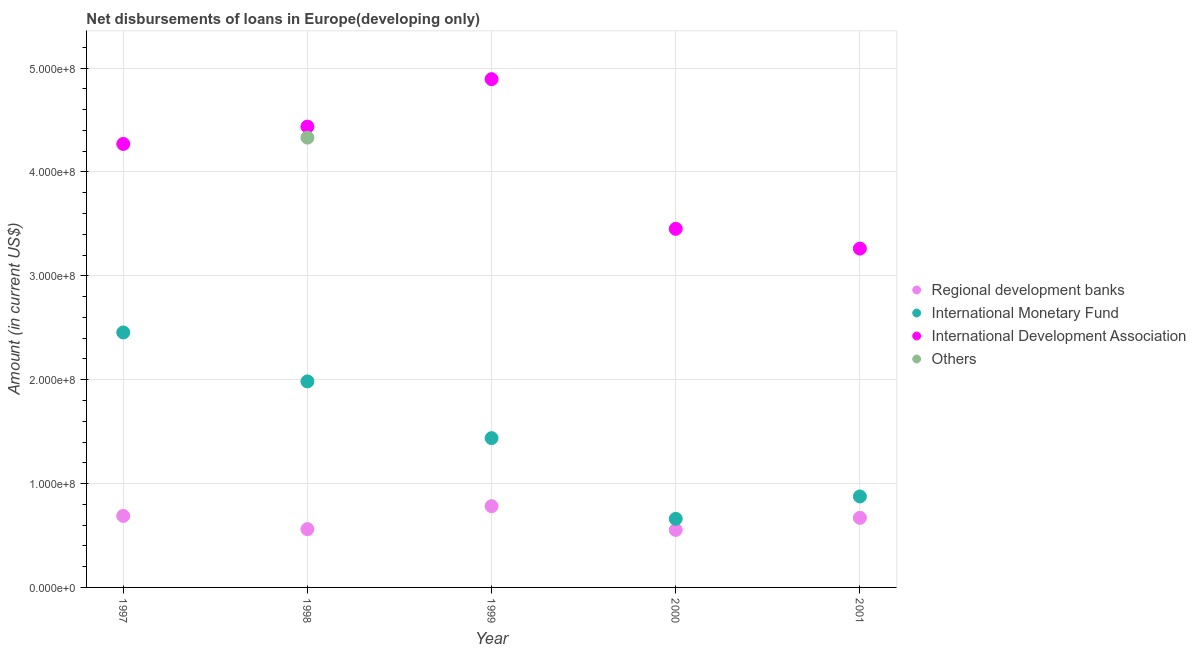How many different coloured dotlines are there?
Provide a short and direct response. 4. What is the amount of loan disimbursed by regional development banks in 1997?
Keep it short and to the point. 6.89e+07. Across all years, what is the maximum amount of loan disimbursed by other organisations?
Offer a terse response. 4.33e+08. Across all years, what is the minimum amount of loan disimbursed by international monetary fund?
Your answer should be very brief. 6.60e+07. In which year was the amount of loan disimbursed by international development association maximum?
Your answer should be compact. 1999. What is the total amount of loan disimbursed by other organisations in the graph?
Provide a short and direct response. 4.33e+08. What is the difference between the amount of loan disimbursed by regional development banks in 1997 and that in 1998?
Provide a short and direct response. 1.27e+07. What is the difference between the amount of loan disimbursed by international development association in 1997 and the amount of loan disimbursed by regional development banks in 2001?
Your answer should be very brief. 3.60e+08. What is the average amount of loan disimbursed by regional development banks per year?
Ensure brevity in your answer.  6.51e+07. In the year 1999, what is the difference between the amount of loan disimbursed by international monetary fund and amount of loan disimbursed by international development association?
Make the answer very short. -3.46e+08. In how many years, is the amount of loan disimbursed by international monetary fund greater than 20000000 US$?
Offer a very short reply. 5. What is the ratio of the amount of loan disimbursed by international development association in 1998 to that in 2001?
Your answer should be compact. 1.36. Is the amount of loan disimbursed by international monetary fund in 1997 less than that in 2001?
Your answer should be very brief. No. Is the difference between the amount of loan disimbursed by international development association in 1997 and 2001 greater than the difference between the amount of loan disimbursed by international monetary fund in 1997 and 2001?
Your response must be concise. No. What is the difference between the highest and the second highest amount of loan disimbursed by regional development banks?
Provide a short and direct response. 9.38e+06. What is the difference between the highest and the lowest amount of loan disimbursed by regional development banks?
Provide a succinct answer. 2.29e+07. In how many years, is the amount of loan disimbursed by international development association greater than the average amount of loan disimbursed by international development association taken over all years?
Provide a short and direct response. 3. Is it the case that in every year, the sum of the amount of loan disimbursed by regional development banks and amount of loan disimbursed by international monetary fund is greater than the amount of loan disimbursed by international development association?
Provide a succinct answer. No. Is the amount of loan disimbursed by international development association strictly less than the amount of loan disimbursed by international monetary fund over the years?
Your response must be concise. No. How many years are there in the graph?
Your answer should be very brief. 5. What is the difference between two consecutive major ticks on the Y-axis?
Provide a succinct answer. 1.00e+08. Are the values on the major ticks of Y-axis written in scientific E-notation?
Your answer should be compact. Yes. Does the graph contain any zero values?
Keep it short and to the point. Yes. Does the graph contain grids?
Your response must be concise. Yes. Where does the legend appear in the graph?
Give a very brief answer. Center right. How many legend labels are there?
Provide a short and direct response. 4. How are the legend labels stacked?
Your answer should be very brief. Vertical. What is the title of the graph?
Make the answer very short. Net disbursements of loans in Europe(developing only). What is the label or title of the Y-axis?
Give a very brief answer. Amount (in current US$). What is the Amount (in current US$) in Regional development banks in 1997?
Offer a very short reply. 6.89e+07. What is the Amount (in current US$) in International Monetary Fund in 1997?
Provide a succinct answer. 2.45e+08. What is the Amount (in current US$) in International Development Association in 1997?
Offer a terse response. 4.27e+08. What is the Amount (in current US$) of Others in 1997?
Provide a succinct answer. 0. What is the Amount (in current US$) in Regional development banks in 1998?
Offer a very short reply. 5.61e+07. What is the Amount (in current US$) in International Monetary Fund in 1998?
Give a very brief answer. 1.98e+08. What is the Amount (in current US$) of International Development Association in 1998?
Offer a very short reply. 4.44e+08. What is the Amount (in current US$) in Others in 1998?
Your answer should be very brief. 4.33e+08. What is the Amount (in current US$) in Regional development banks in 1999?
Make the answer very short. 7.82e+07. What is the Amount (in current US$) in International Monetary Fund in 1999?
Provide a succinct answer. 1.44e+08. What is the Amount (in current US$) of International Development Association in 1999?
Your answer should be very brief. 4.89e+08. What is the Amount (in current US$) in Others in 1999?
Ensure brevity in your answer.  0. What is the Amount (in current US$) of Regional development banks in 2000?
Ensure brevity in your answer.  5.54e+07. What is the Amount (in current US$) of International Monetary Fund in 2000?
Your answer should be compact. 6.60e+07. What is the Amount (in current US$) in International Development Association in 2000?
Offer a terse response. 3.45e+08. What is the Amount (in current US$) of Regional development banks in 2001?
Your answer should be compact. 6.70e+07. What is the Amount (in current US$) in International Monetary Fund in 2001?
Provide a succinct answer. 8.76e+07. What is the Amount (in current US$) of International Development Association in 2001?
Your response must be concise. 3.26e+08. What is the Amount (in current US$) in Others in 2001?
Ensure brevity in your answer.  0. Across all years, what is the maximum Amount (in current US$) of Regional development banks?
Provide a short and direct response. 7.82e+07. Across all years, what is the maximum Amount (in current US$) in International Monetary Fund?
Offer a very short reply. 2.45e+08. Across all years, what is the maximum Amount (in current US$) in International Development Association?
Ensure brevity in your answer.  4.89e+08. Across all years, what is the maximum Amount (in current US$) of Others?
Your response must be concise. 4.33e+08. Across all years, what is the minimum Amount (in current US$) in Regional development banks?
Offer a terse response. 5.54e+07. Across all years, what is the minimum Amount (in current US$) in International Monetary Fund?
Provide a short and direct response. 6.60e+07. Across all years, what is the minimum Amount (in current US$) of International Development Association?
Offer a terse response. 3.26e+08. Across all years, what is the minimum Amount (in current US$) in Others?
Your answer should be compact. 0. What is the total Amount (in current US$) of Regional development banks in the graph?
Make the answer very short. 3.26e+08. What is the total Amount (in current US$) of International Monetary Fund in the graph?
Give a very brief answer. 7.41e+08. What is the total Amount (in current US$) of International Development Association in the graph?
Provide a succinct answer. 2.03e+09. What is the total Amount (in current US$) in Others in the graph?
Provide a short and direct response. 4.33e+08. What is the difference between the Amount (in current US$) of Regional development banks in 1997 and that in 1998?
Your answer should be compact. 1.27e+07. What is the difference between the Amount (in current US$) in International Monetary Fund in 1997 and that in 1998?
Offer a very short reply. 4.71e+07. What is the difference between the Amount (in current US$) of International Development Association in 1997 and that in 1998?
Give a very brief answer. -1.67e+07. What is the difference between the Amount (in current US$) of Regional development banks in 1997 and that in 1999?
Offer a terse response. -9.38e+06. What is the difference between the Amount (in current US$) of International Monetary Fund in 1997 and that in 1999?
Offer a terse response. 1.02e+08. What is the difference between the Amount (in current US$) of International Development Association in 1997 and that in 1999?
Give a very brief answer. -6.24e+07. What is the difference between the Amount (in current US$) in Regional development banks in 1997 and that in 2000?
Your answer should be compact. 1.35e+07. What is the difference between the Amount (in current US$) in International Monetary Fund in 1997 and that in 2000?
Offer a terse response. 1.79e+08. What is the difference between the Amount (in current US$) of International Development Association in 1997 and that in 2000?
Give a very brief answer. 8.17e+07. What is the difference between the Amount (in current US$) in Regional development banks in 1997 and that in 2001?
Offer a very short reply. 1.84e+06. What is the difference between the Amount (in current US$) in International Monetary Fund in 1997 and that in 2001?
Keep it short and to the point. 1.58e+08. What is the difference between the Amount (in current US$) of International Development Association in 1997 and that in 2001?
Give a very brief answer. 1.01e+08. What is the difference between the Amount (in current US$) of Regional development banks in 1998 and that in 1999?
Your response must be concise. -2.21e+07. What is the difference between the Amount (in current US$) of International Monetary Fund in 1998 and that in 1999?
Provide a succinct answer. 5.46e+07. What is the difference between the Amount (in current US$) in International Development Association in 1998 and that in 1999?
Give a very brief answer. -4.57e+07. What is the difference between the Amount (in current US$) in Regional development banks in 1998 and that in 2000?
Provide a short and direct response. 7.39e+05. What is the difference between the Amount (in current US$) in International Monetary Fund in 1998 and that in 2000?
Ensure brevity in your answer.  1.32e+08. What is the difference between the Amount (in current US$) in International Development Association in 1998 and that in 2000?
Offer a terse response. 9.84e+07. What is the difference between the Amount (in current US$) in Regional development banks in 1998 and that in 2001?
Your answer should be compact. -1.09e+07. What is the difference between the Amount (in current US$) of International Monetary Fund in 1998 and that in 2001?
Make the answer very short. 1.11e+08. What is the difference between the Amount (in current US$) of International Development Association in 1998 and that in 2001?
Make the answer very short. 1.17e+08. What is the difference between the Amount (in current US$) in Regional development banks in 1999 and that in 2000?
Make the answer very short. 2.29e+07. What is the difference between the Amount (in current US$) in International Monetary Fund in 1999 and that in 2000?
Make the answer very short. 7.77e+07. What is the difference between the Amount (in current US$) of International Development Association in 1999 and that in 2000?
Provide a succinct answer. 1.44e+08. What is the difference between the Amount (in current US$) in Regional development banks in 1999 and that in 2001?
Offer a terse response. 1.12e+07. What is the difference between the Amount (in current US$) of International Monetary Fund in 1999 and that in 2001?
Offer a terse response. 5.62e+07. What is the difference between the Amount (in current US$) of International Development Association in 1999 and that in 2001?
Ensure brevity in your answer.  1.63e+08. What is the difference between the Amount (in current US$) in Regional development banks in 2000 and that in 2001?
Give a very brief answer. -1.16e+07. What is the difference between the Amount (in current US$) in International Monetary Fund in 2000 and that in 2001?
Offer a terse response. -2.15e+07. What is the difference between the Amount (in current US$) of International Development Association in 2000 and that in 2001?
Provide a succinct answer. 1.90e+07. What is the difference between the Amount (in current US$) of Regional development banks in 1997 and the Amount (in current US$) of International Monetary Fund in 1998?
Give a very brief answer. -1.30e+08. What is the difference between the Amount (in current US$) in Regional development banks in 1997 and the Amount (in current US$) in International Development Association in 1998?
Your answer should be compact. -3.75e+08. What is the difference between the Amount (in current US$) of Regional development banks in 1997 and the Amount (in current US$) of Others in 1998?
Offer a terse response. -3.64e+08. What is the difference between the Amount (in current US$) in International Monetary Fund in 1997 and the Amount (in current US$) in International Development Association in 1998?
Provide a short and direct response. -1.98e+08. What is the difference between the Amount (in current US$) of International Monetary Fund in 1997 and the Amount (in current US$) of Others in 1998?
Your answer should be compact. -1.88e+08. What is the difference between the Amount (in current US$) in International Development Association in 1997 and the Amount (in current US$) in Others in 1998?
Provide a short and direct response. -6.06e+06. What is the difference between the Amount (in current US$) in Regional development banks in 1997 and the Amount (in current US$) in International Monetary Fund in 1999?
Make the answer very short. -7.49e+07. What is the difference between the Amount (in current US$) of Regional development banks in 1997 and the Amount (in current US$) of International Development Association in 1999?
Give a very brief answer. -4.21e+08. What is the difference between the Amount (in current US$) in International Monetary Fund in 1997 and the Amount (in current US$) in International Development Association in 1999?
Your answer should be very brief. -2.44e+08. What is the difference between the Amount (in current US$) in Regional development banks in 1997 and the Amount (in current US$) in International Monetary Fund in 2000?
Provide a succinct answer. 2.83e+06. What is the difference between the Amount (in current US$) in Regional development banks in 1997 and the Amount (in current US$) in International Development Association in 2000?
Offer a very short reply. -2.76e+08. What is the difference between the Amount (in current US$) in International Monetary Fund in 1997 and the Amount (in current US$) in International Development Association in 2000?
Your response must be concise. -9.98e+07. What is the difference between the Amount (in current US$) of Regional development banks in 1997 and the Amount (in current US$) of International Monetary Fund in 2001?
Your response must be concise. -1.87e+07. What is the difference between the Amount (in current US$) in Regional development banks in 1997 and the Amount (in current US$) in International Development Association in 2001?
Your answer should be compact. -2.57e+08. What is the difference between the Amount (in current US$) of International Monetary Fund in 1997 and the Amount (in current US$) of International Development Association in 2001?
Your response must be concise. -8.08e+07. What is the difference between the Amount (in current US$) in Regional development banks in 1998 and the Amount (in current US$) in International Monetary Fund in 1999?
Provide a short and direct response. -8.76e+07. What is the difference between the Amount (in current US$) of Regional development banks in 1998 and the Amount (in current US$) of International Development Association in 1999?
Ensure brevity in your answer.  -4.33e+08. What is the difference between the Amount (in current US$) in International Monetary Fund in 1998 and the Amount (in current US$) in International Development Association in 1999?
Offer a terse response. -2.91e+08. What is the difference between the Amount (in current US$) in Regional development banks in 1998 and the Amount (in current US$) in International Monetary Fund in 2000?
Keep it short and to the point. -9.90e+06. What is the difference between the Amount (in current US$) in Regional development banks in 1998 and the Amount (in current US$) in International Development Association in 2000?
Offer a terse response. -2.89e+08. What is the difference between the Amount (in current US$) of International Monetary Fund in 1998 and the Amount (in current US$) of International Development Association in 2000?
Provide a short and direct response. -1.47e+08. What is the difference between the Amount (in current US$) of Regional development banks in 1998 and the Amount (in current US$) of International Monetary Fund in 2001?
Your answer should be compact. -3.15e+07. What is the difference between the Amount (in current US$) of Regional development banks in 1998 and the Amount (in current US$) of International Development Association in 2001?
Offer a very short reply. -2.70e+08. What is the difference between the Amount (in current US$) in International Monetary Fund in 1998 and the Amount (in current US$) in International Development Association in 2001?
Offer a terse response. -1.28e+08. What is the difference between the Amount (in current US$) in Regional development banks in 1999 and the Amount (in current US$) in International Monetary Fund in 2000?
Make the answer very short. 1.22e+07. What is the difference between the Amount (in current US$) of Regional development banks in 1999 and the Amount (in current US$) of International Development Association in 2000?
Your response must be concise. -2.67e+08. What is the difference between the Amount (in current US$) in International Monetary Fund in 1999 and the Amount (in current US$) in International Development Association in 2000?
Give a very brief answer. -2.01e+08. What is the difference between the Amount (in current US$) of Regional development banks in 1999 and the Amount (in current US$) of International Monetary Fund in 2001?
Your response must be concise. -9.34e+06. What is the difference between the Amount (in current US$) in Regional development banks in 1999 and the Amount (in current US$) in International Development Association in 2001?
Your response must be concise. -2.48e+08. What is the difference between the Amount (in current US$) in International Monetary Fund in 1999 and the Amount (in current US$) in International Development Association in 2001?
Your answer should be very brief. -1.82e+08. What is the difference between the Amount (in current US$) in Regional development banks in 2000 and the Amount (in current US$) in International Monetary Fund in 2001?
Your answer should be compact. -3.22e+07. What is the difference between the Amount (in current US$) of Regional development banks in 2000 and the Amount (in current US$) of International Development Association in 2001?
Give a very brief answer. -2.71e+08. What is the difference between the Amount (in current US$) of International Monetary Fund in 2000 and the Amount (in current US$) of International Development Association in 2001?
Your answer should be very brief. -2.60e+08. What is the average Amount (in current US$) in Regional development banks per year?
Make the answer very short. 6.51e+07. What is the average Amount (in current US$) in International Monetary Fund per year?
Your response must be concise. 1.48e+08. What is the average Amount (in current US$) of International Development Association per year?
Ensure brevity in your answer.  4.06e+08. What is the average Amount (in current US$) of Others per year?
Your answer should be compact. 8.66e+07. In the year 1997, what is the difference between the Amount (in current US$) of Regional development banks and Amount (in current US$) of International Monetary Fund?
Your answer should be compact. -1.77e+08. In the year 1997, what is the difference between the Amount (in current US$) in Regional development banks and Amount (in current US$) in International Development Association?
Your answer should be compact. -3.58e+08. In the year 1997, what is the difference between the Amount (in current US$) in International Monetary Fund and Amount (in current US$) in International Development Association?
Offer a very short reply. -1.82e+08. In the year 1998, what is the difference between the Amount (in current US$) in Regional development banks and Amount (in current US$) in International Monetary Fund?
Your response must be concise. -1.42e+08. In the year 1998, what is the difference between the Amount (in current US$) of Regional development banks and Amount (in current US$) of International Development Association?
Provide a short and direct response. -3.88e+08. In the year 1998, what is the difference between the Amount (in current US$) in Regional development banks and Amount (in current US$) in Others?
Ensure brevity in your answer.  -3.77e+08. In the year 1998, what is the difference between the Amount (in current US$) of International Monetary Fund and Amount (in current US$) of International Development Association?
Provide a succinct answer. -2.45e+08. In the year 1998, what is the difference between the Amount (in current US$) in International Monetary Fund and Amount (in current US$) in Others?
Make the answer very short. -2.35e+08. In the year 1998, what is the difference between the Amount (in current US$) of International Development Association and Amount (in current US$) of Others?
Make the answer very short. 1.06e+07. In the year 1999, what is the difference between the Amount (in current US$) of Regional development banks and Amount (in current US$) of International Monetary Fund?
Ensure brevity in your answer.  -6.55e+07. In the year 1999, what is the difference between the Amount (in current US$) of Regional development banks and Amount (in current US$) of International Development Association?
Ensure brevity in your answer.  -4.11e+08. In the year 1999, what is the difference between the Amount (in current US$) of International Monetary Fund and Amount (in current US$) of International Development Association?
Your answer should be compact. -3.46e+08. In the year 2000, what is the difference between the Amount (in current US$) of Regional development banks and Amount (in current US$) of International Monetary Fund?
Your answer should be compact. -1.06e+07. In the year 2000, what is the difference between the Amount (in current US$) in Regional development banks and Amount (in current US$) in International Development Association?
Your answer should be very brief. -2.90e+08. In the year 2000, what is the difference between the Amount (in current US$) in International Monetary Fund and Amount (in current US$) in International Development Association?
Provide a succinct answer. -2.79e+08. In the year 2001, what is the difference between the Amount (in current US$) in Regional development banks and Amount (in current US$) in International Monetary Fund?
Provide a succinct answer. -2.06e+07. In the year 2001, what is the difference between the Amount (in current US$) in Regional development banks and Amount (in current US$) in International Development Association?
Give a very brief answer. -2.59e+08. In the year 2001, what is the difference between the Amount (in current US$) of International Monetary Fund and Amount (in current US$) of International Development Association?
Your answer should be very brief. -2.39e+08. What is the ratio of the Amount (in current US$) in Regional development banks in 1997 to that in 1998?
Make the answer very short. 1.23. What is the ratio of the Amount (in current US$) in International Monetary Fund in 1997 to that in 1998?
Provide a succinct answer. 1.24. What is the ratio of the Amount (in current US$) in International Development Association in 1997 to that in 1998?
Your answer should be compact. 0.96. What is the ratio of the Amount (in current US$) of Regional development banks in 1997 to that in 1999?
Ensure brevity in your answer.  0.88. What is the ratio of the Amount (in current US$) in International Monetary Fund in 1997 to that in 1999?
Provide a succinct answer. 1.71. What is the ratio of the Amount (in current US$) of International Development Association in 1997 to that in 1999?
Provide a succinct answer. 0.87. What is the ratio of the Amount (in current US$) of Regional development banks in 1997 to that in 2000?
Provide a short and direct response. 1.24. What is the ratio of the Amount (in current US$) in International Monetary Fund in 1997 to that in 2000?
Your answer should be compact. 3.72. What is the ratio of the Amount (in current US$) of International Development Association in 1997 to that in 2000?
Your response must be concise. 1.24. What is the ratio of the Amount (in current US$) of Regional development banks in 1997 to that in 2001?
Your answer should be compact. 1.03. What is the ratio of the Amount (in current US$) of International Monetary Fund in 1997 to that in 2001?
Offer a terse response. 2.8. What is the ratio of the Amount (in current US$) of International Development Association in 1997 to that in 2001?
Provide a succinct answer. 1.31. What is the ratio of the Amount (in current US$) of Regional development banks in 1998 to that in 1999?
Your answer should be very brief. 0.72. What is the ratio of the Amount (in current US$) of International Monetary Fund in 1998 to that in 1999?
Give a very brief answer. 1.38. What is the ratio of the Amount (in current US$) of International Development Association in 1998 to that in 1999?
Your answer should be very brief. 0.91. What is the ratio of the Amount (in current US$) in Regional development banks in 1998 to that in 2000?
Offer a very short reply. 1.01. What is the ratio of the Amount (in current US$) of International Monetary Fund in 1998 to that in 2000?
Your answer should be very brief. 3. What is the ratio of the Amount (in current US$) of International Development Association in 1998 to that in 2000?
Keep it short and to the point. 1.28. What is the ratio of the Amount (in current US$) of Regional development banks in 1998 to that in 2001?
Offer a very short reply. 0.84. What is the ratio of the Amount (in current US$) of International Monetary Fund in 1998 to that in 2001?
Provide a short and direct response. 2.27. What is the ratio of the Amount (in current US$) of International Development Association in 1998 to that in 2001?
Keep it short and to the point. 1.36. What is the ratio of the Amount (in current US$) in Regional development banks in 1999 to that in 2000?
Offer a terse response. 1.41. What is the ratio of the Amount (in current US$) of International Monetary Fund in 1999 to that in 2000?
Your answer should be compact. 2.18. What is the ratio of the Amount (in current US$) in International Development Association in 1999 to that in 2000?
Ensure brevity in your answer.  1.42. What is the ratio of the Amount (in current US$) of Regional development banks in 1999 to that in 2001?
Offer a very short reply. 1.17. What is the ratio of the Amount (in current US$) of International Monetary Fund in 1999 to that in 2001?
Give a very brief answer. 1.64. What is the ratio of the Amount (in current US$) of Regional development banks in 2000 to that in 2001?
Provide a succinct answer. 0.83. What is the ratio of the Amount (in current US$) in International Monetary Fund in 2000 to that in 2001?
Offer a terse response. 0.75. What is the ratio of the Amount (in current US$) in International Development Association in 2000 to that in 2001?
Your response must be concise. 1.06. What is the difference between the highest and the second highest Amount (in current US$) in Regional development banks?
Keep it short and to the point. 9.38e+06. What is the difference between the highest and the second highest Amount (in current US$) in International Monetary Fund?
Give a very brief answer. 4.71e+07. What is the difference between the highest and the second highest Amount (in current US$) in International Development Association?
Ensure brevity in your answer.  4.57e+07. What is the difference between the highest and the lowest Amount (in current US$) in Regional development banks?
Keep it short and to the point. 2.29e+07. What is the difference between the highest and the lowest Amount (in current US$) of International Monetary Fund?
Your answer should be very brief. 1.79e+08. What is the difference between the highest and the lowest Amount (in current US$) in International Development Association?
Provide a succinct answer. 1.63e+08. What is the difference between the highest and the lowest Amount (in current US$) of Others?
Give a very brief answer. 4.33e+08. 